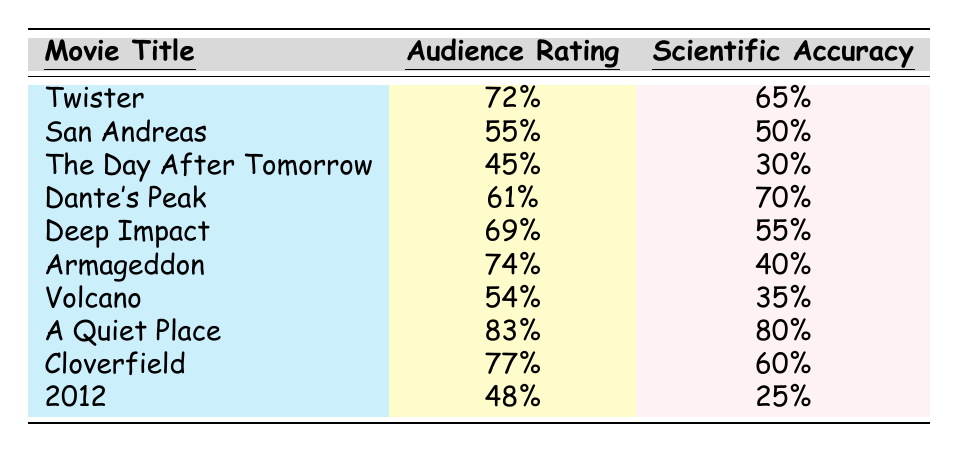What is the audience rating of "A Quiet Place"? The table shows the audience rating for each movie, and for "A Quiet Place," the rating is listed as 83%.
Answer: 83% Which movie has the highest scientific accuracy rating? By examining the scientific accuracy values in the table, "A Quiet Place" has the highest rating at 80%.
Answer: A Quiet Place What is the difference between the audience rating of "Twister" and "San Andreas"? The audience rating of "Twister" is 72%, and for "San Andreas," it is 55%. The difference is 72% - 55% = 17%.
Answer: 17% What is the average scientific accuracy rating of the movies listed? To find the average, sum the scientific accuracy ratings: 65 + 50 + 30 + 70 + 55 + 40 + 35 + 80 + 60 + 25 =  485. There are 10 movies, so the average is 485 / 10 = 48.5%.
Answer: 48.5% Is the scientific accuracy of "Deep Impact" greater than its audience rating? "Deep Impact" has a scientific accuracy rating of 55% while its audience rating is 69%. Since 55% is less than 69%, the statement is false.
Answer: No Which movie had the lowest audience rating? The table indicates that "The Day After Tomorrow" has the lowest audience rating at 45%.
Answer: The Day After Tomorrow How many movies have an audience rating of 70% or higher? The movies with an audience rating of 70% or higher are "Twister" (72%), "Armageddon" (74%), "Cloverfield" (77%), and "A Quiet Place" (83%). This gives a total of 4 movies.
Answer: 4 What is the total audience rating of all movies combined? Adding the audience ratings gives: 72 + 55 + 45 + 61 + 69 + 74 + 54 + 83 + 77 + 48 =  708.
Answer: 708 Which movie has an audience rating closest to its scientific accuracy? The movie "Dante's Peak" has an audience rating of 61% and scientific accuracy of 70%. The difference is 9%. No other movie has a smaller difference.
Answer: Dante's Peak Is the audience rating of "Armageddon" higher than that of "The Day After Tomorrow"? The audience rating of "Armageddon" is 74%, while "The Day After Tomorrow" is 45%. Since 74% is greater than 45%, the statement is true.
Answer: Yes 